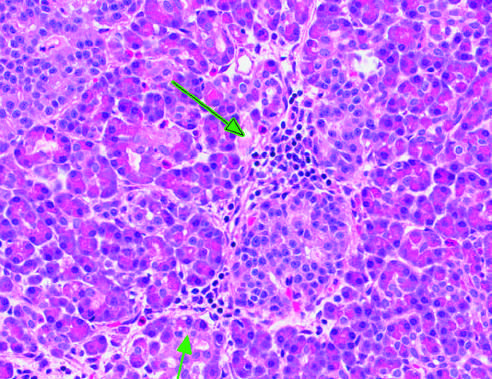re the surrounding acinar structures essentially normal?
Answer the question using a single word or phrase. Yes 